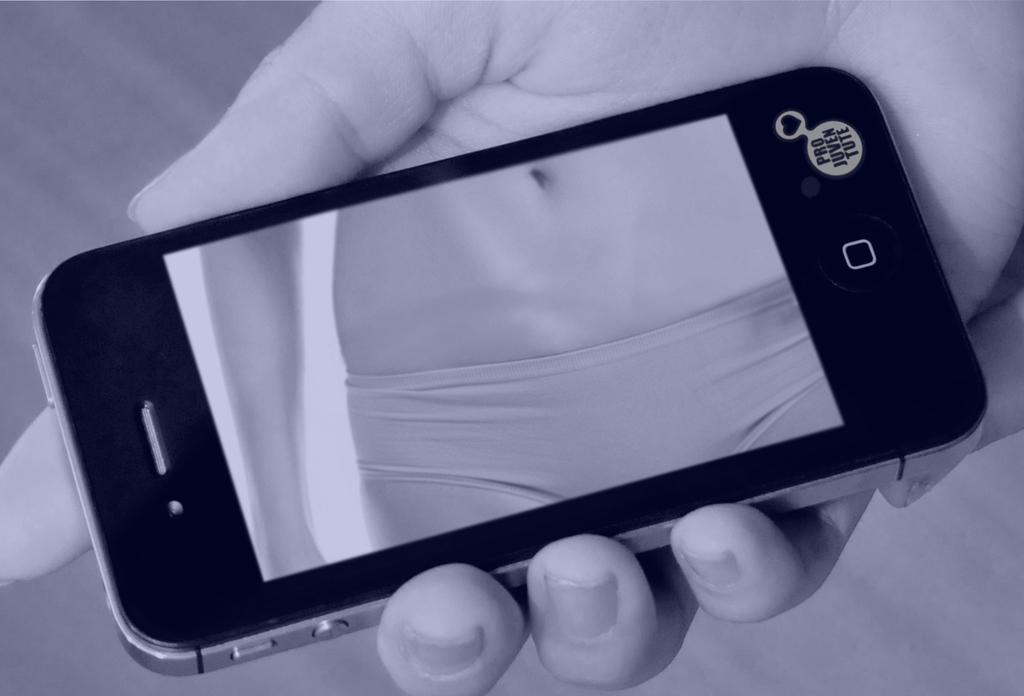In one or two sentences, can you explain what this image depicts? In this image there is a mobile phone on the person's hand. 